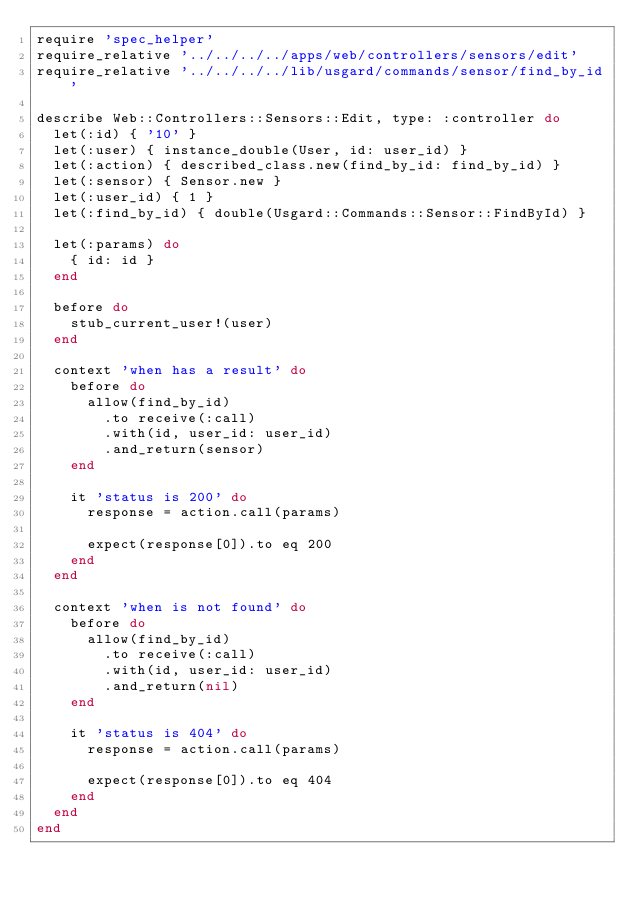Convert code to text. <code><loc_0><loc_0><loc_500><loc_500><_Ruby_>require 'spec_helper'
require_relative '../../../../apps/web/controllers/sensors/edit'
require_relative '../../../../lib/usgard/commands/sensor/find_by_id'

describe Web::Controllers::Sensors::Edit, type: :controller do
  let(:id) { '10' }
  let(:user) { instance_double(User, id: user_id) }
  let(:action) { described_class.new(find_by_id: find_by_id) }
  let(:sensor) { Sensor.new }
  let(:user_id) { 1 }
  let(:find_by_id) { double(Usgard::Commands::Sensor::FindById) }

  let(:params) do
    { id: id }
  end

  before do
    stub_current_user!(user)
  end

  context 'when has a result' do
    before do
      allow(find_by_id)
        .to receive(:call)
        .with(id, user_id: user_id)
        .and_return(sensor)
    end

    it 'status is 200' do
      response = action.call(params)

      expect(response[0]).to eq 200
    end
  end

  context 'when is not found' do
    before do
      allow(find_by_id)
        .to receive(:call)
        .with(id, user_id: user_id)
        .and_return(nil)
    end

    it 'status is 404' do
      response = action.call(params)

      expect(response[0]).to eq 404
    end
  end
end
</code> 